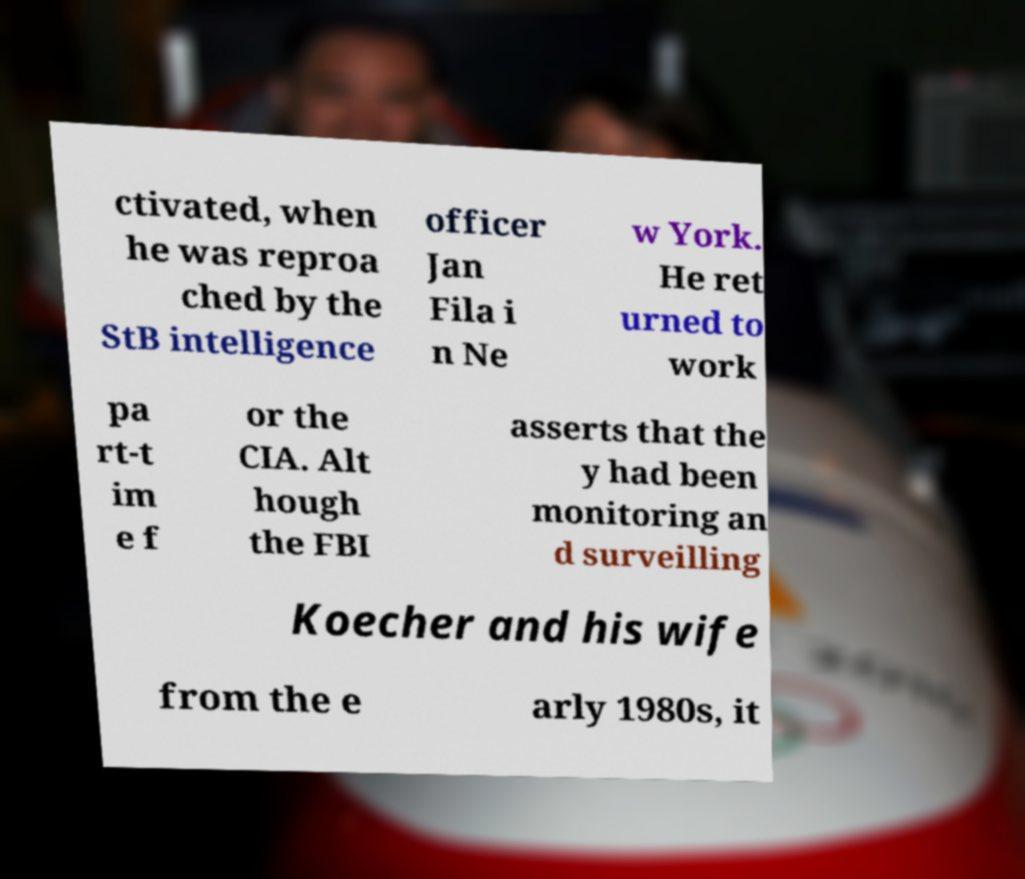Could you extract and type out the text from this image? ctivated, when he was reproa ched by the StB intelligence officer Jan Fila i n Ne w York. He ret urned to work pa rt-t im e f or the CIA. Alt hough the FBI asserts that the y had been monitoring an d surveilling Koecher and his wife from the e arly 1980s, it 